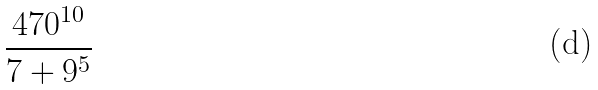<formula> <loc_0><loc_0><loc_500><loc_500>\frac { 4 7 0 ^ { 1 0 } } { 7 + 9 ^ { 5 } }</formula> 